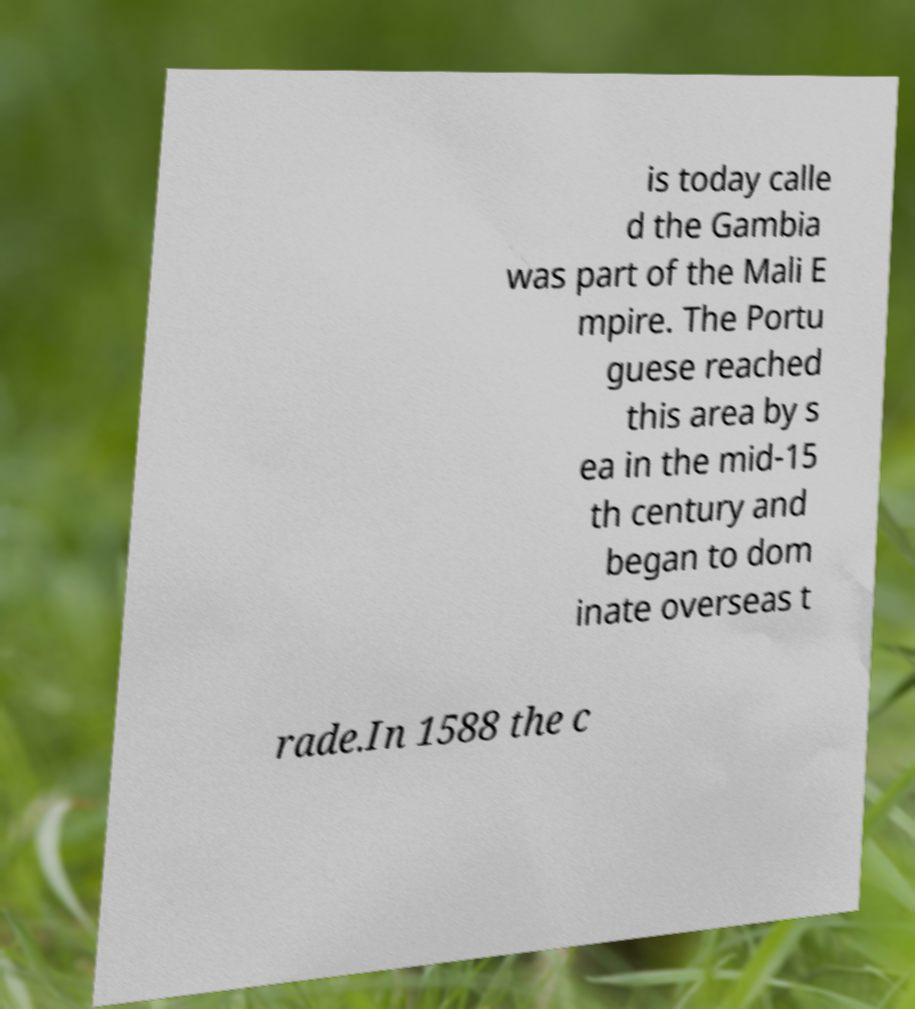Please identify and transcribe the text found in this image. is today calle d the Gambia was part of the Mali E mpire. The Portu guese reached this area by s ea in the mid-15 th century and began to dom inate overseas t rade.In 1588 the c 